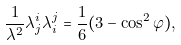<formula> <loc_0><loc_0><loc_500><loc_500>\frac { 1 } { \lambda ^ { 2 } } \lambda _ { j } ^ { i } \lambda _ { i } ^ { j } = \frac { 1 } { 6 } ( 3 - \cos ^ { 2 } \varphi ) ,</formula> 